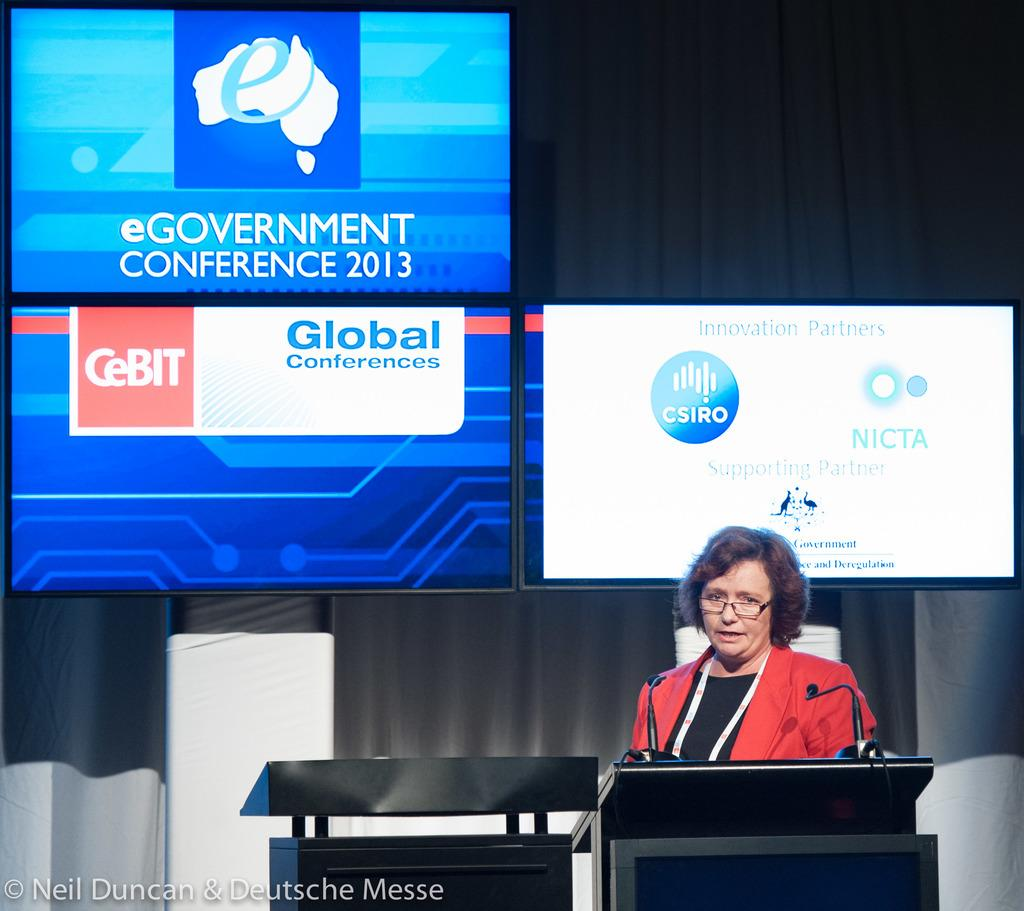<image>
Render a clear and concise summary of the photo. A woman is giving a presentation at the eGovernment conference in 2013. 